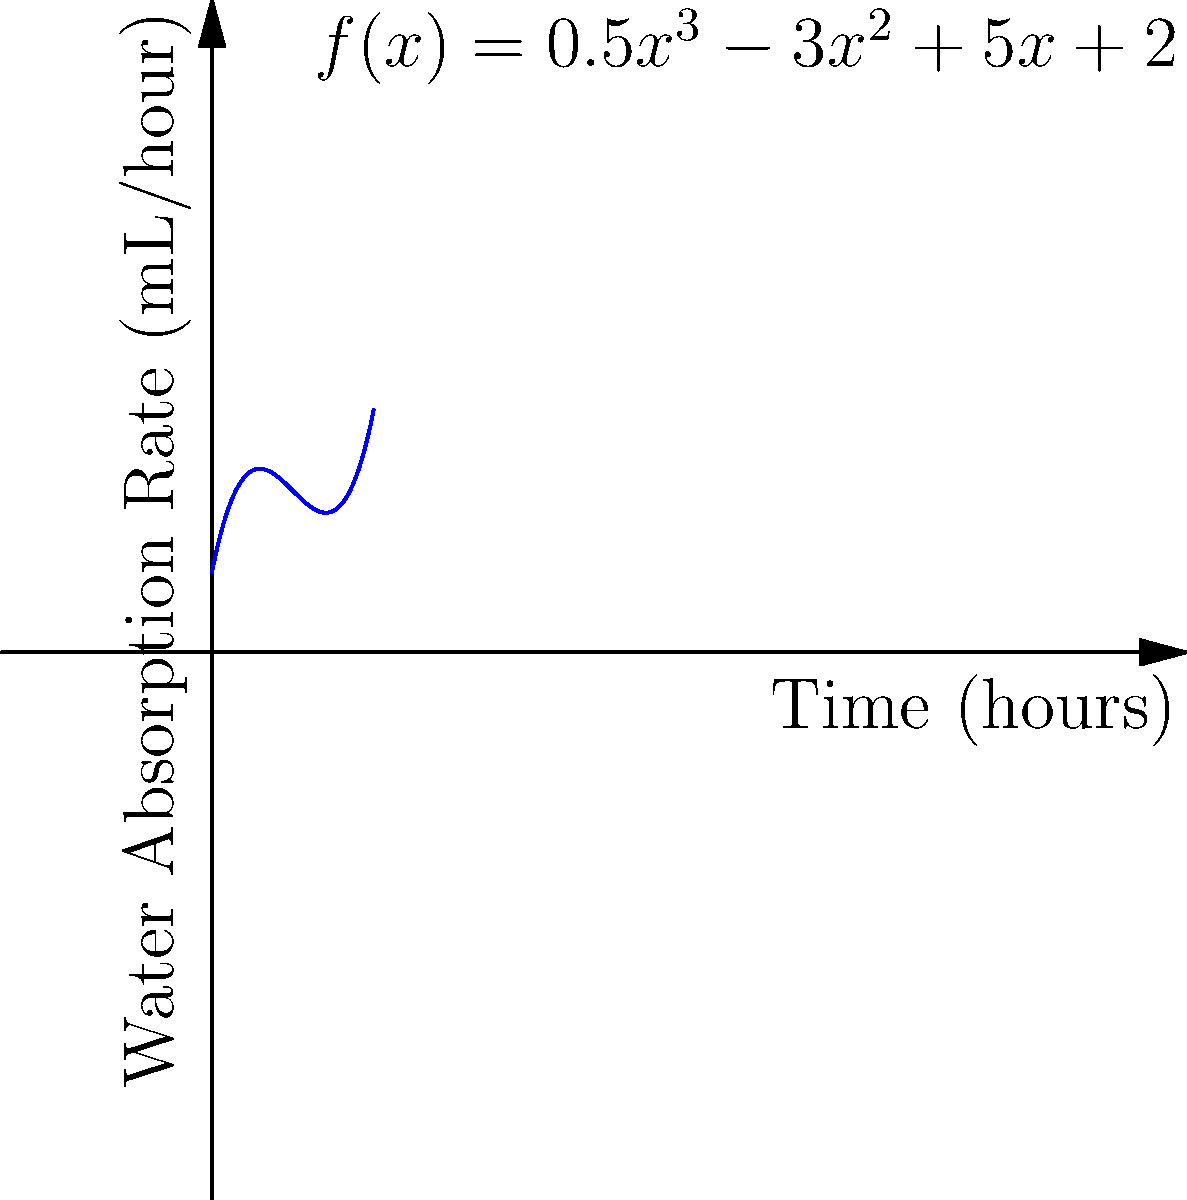As a garden columnist, you're studying water absorption rates in different soil types. The graph shows a polynomial function $f(x) = 0.5x^3 - 3x^2 + 5x + 2$ representing the rate of water absorption (in mL/hour) over time (in hours) for a particular soil sample. At what time does the water absorption rate reach its minimum value within the first 4 hours? To find the minimum point of the function within the given interval, we need to follow these steps:

1) First, we need to find the derivative of the function:
   $f'(x) = 1.5x^2 - 6x + 5$

2) Set the derivative equal to zero to find critical points:
   $1.5x^2 - 6x + 5 = 0$

3) This is a quadratic equation. We can solve it using the quadratic formula:
   $x = \frac{-b \pm \sqrt{b^2 - 4ac}}{2a}$

   Where $a = 1.5$, $b = -6$, and $c = 5$

4) Plugging in these values:
   $x = \frac{6 \pm \sqrt{36 - 30}}{3} = \frac{6 \pm \sqrt{6}}{3}$

5) This gives us two critical points:
   $x_1 = \frac{6 + \sqrt{6}}{3} \approx 2.82$ and $x_2 = \frac{6 - \sqrt{6}}{3} \approx 1.18$

6) Since we're asked about the minimum within the first 4 hours, and both critical points are within this range, we need to evaluate the function at both points and at the endpoints (0 and 4) to determine which gives the minimum value.

7) Evaluating $f(x)$ at these points:
   $f(0) = 2$
   $f(1.18) \approx 1.77$ (minimum)
   $f(2.82) \approx 8.23$
   $f(4) = 26$

Therefore, the minimum occurs at approximately 1.18 hours.
Answer: 1.18 hours 